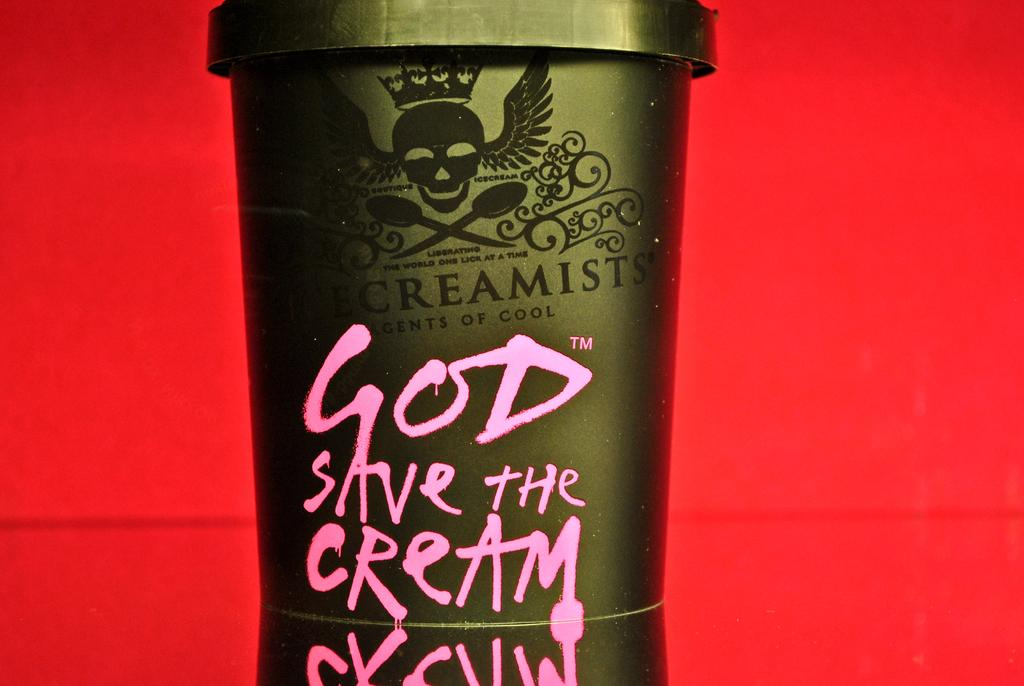<image>
Render a clear and concise summary of the photo. A close up of a odd looking carton of cream. 